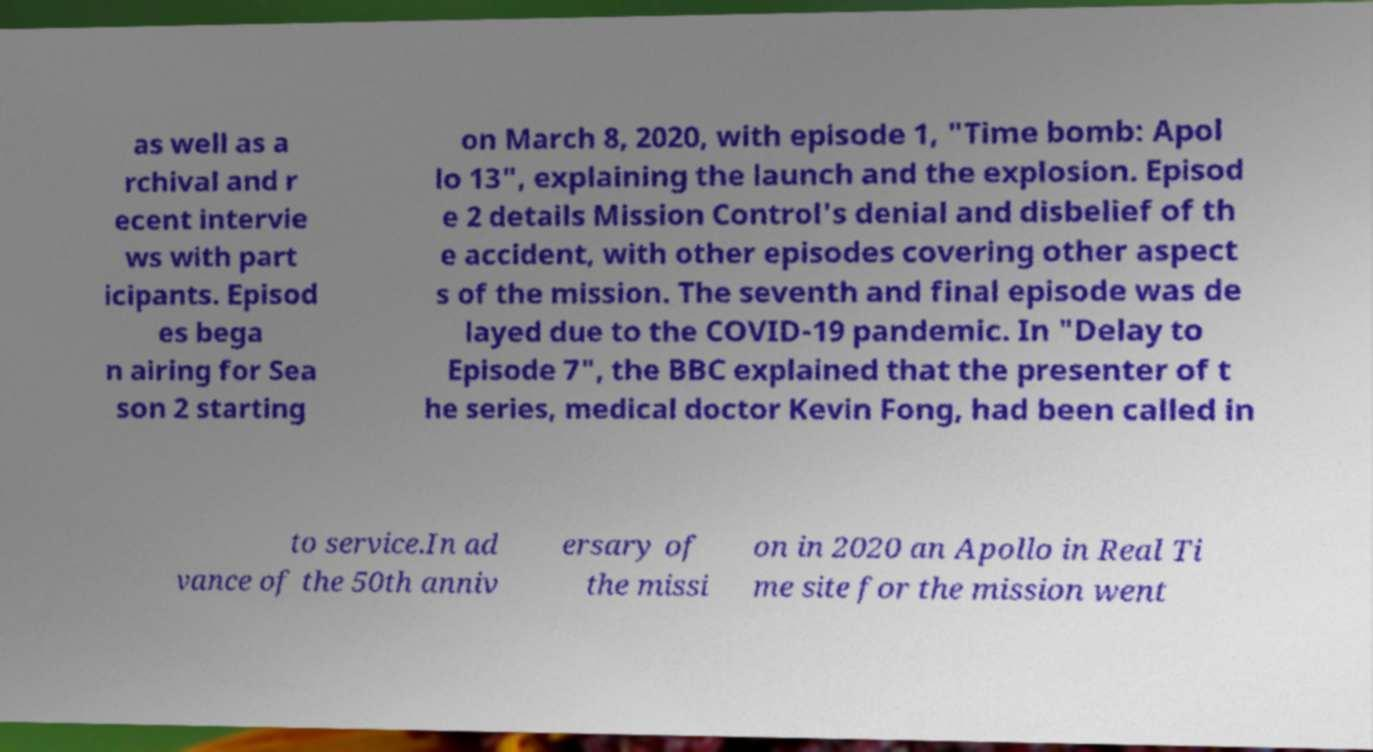There's text embedded in this image that I need extracted. Can you transcribe it verbatim? as well as a rchival and r ecent intervie ws with part icipants. Episod es bega n airing for Sea son 2 starting on March 8, 2020, with episode 1, "Time bomb: Apol lo 13", explaining the launch and the explosion. Episod e 2 details Mission Control's denial and disbelief of th e accident, with other episodes covering other aspect s of the mission. The seventh and final episode was de layed due to the COVID-19 pandemic. In "Delay to Episode 7", the BBC explained that the presenter of t he series, medical doctor Kevin Fong, had been called in to service.In ad vance of the 50th anniv ersary of the missi on in 2020 an Apollo in Real Ti me site for the mission went 